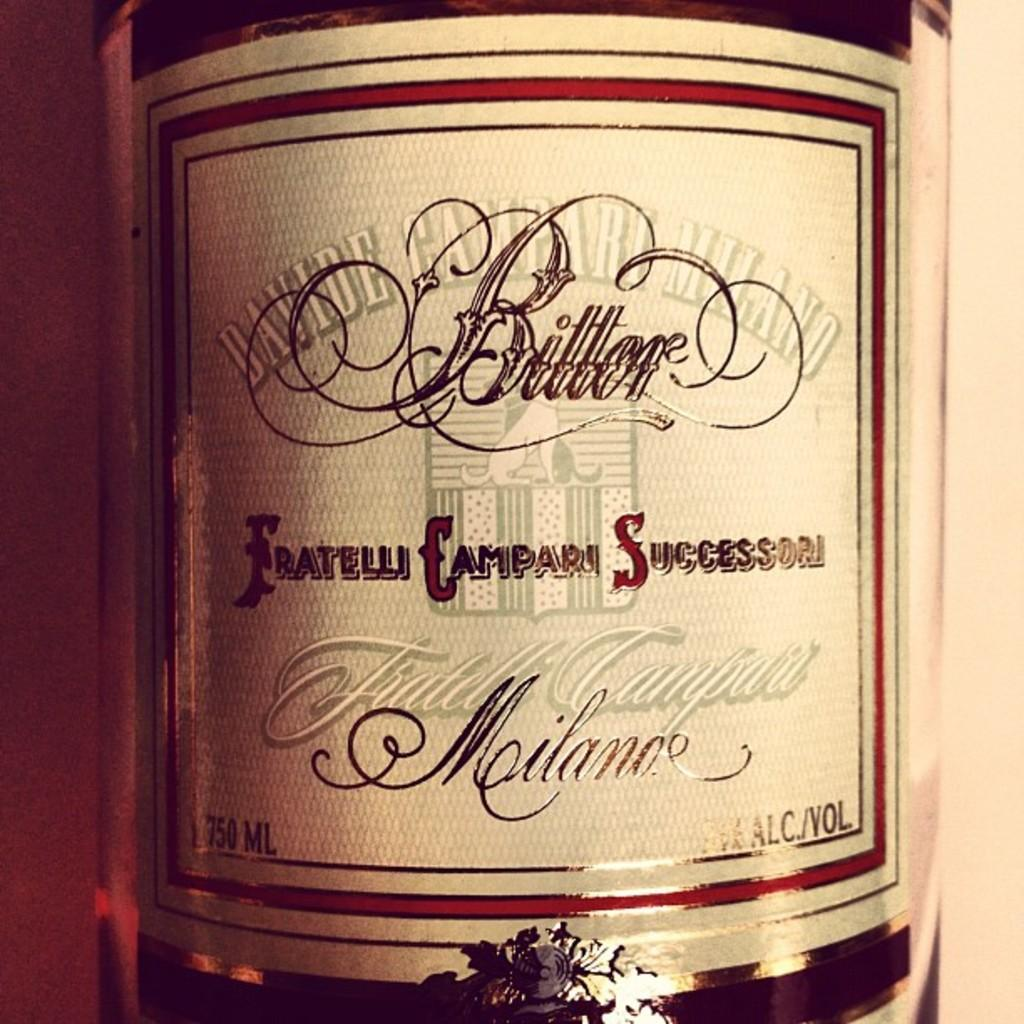<image>
Relay a brief, clear account of the picture shown. A bottle of spirits which has the word Successori on it. 